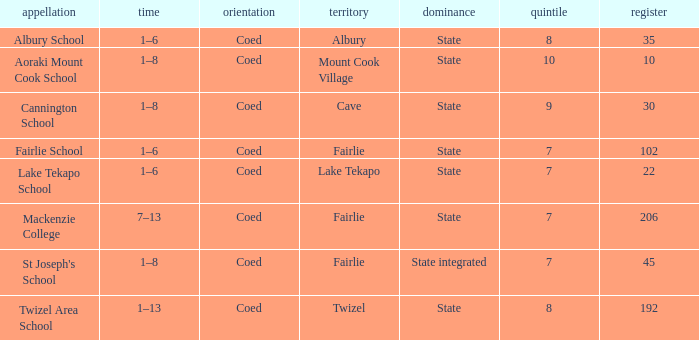What is the total Decile that has a state authority, fairlie area and roll smarter than 206? 1.0. 